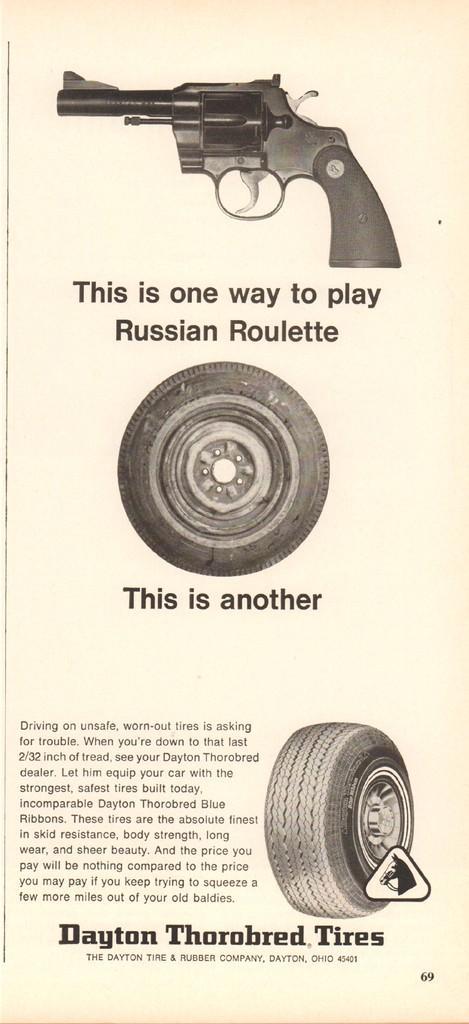Describe this image in one or two sentences. In this picture there is a poster in the image, which consists of pistol. 